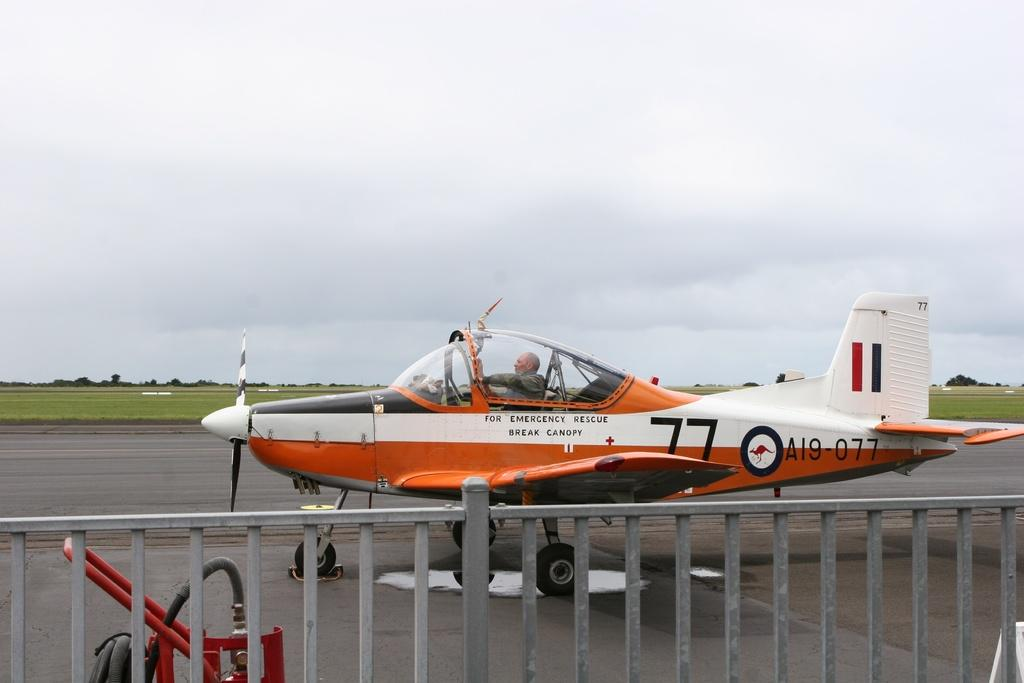<image>
Describe the image concisely. A man is closing the canopy on the small airplane numbered A19-077. 